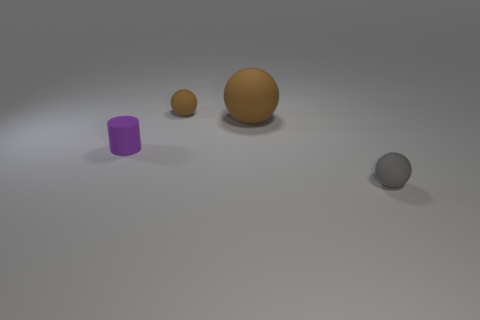Is there any other thing that has the same shape as the tiny purple matte object?
Your answer should be compact. No. What number of spheres are in front of the tiny brown matte sphere and behind the matte cylinder?
Give a very brief answer. 1. What shape is the tiny object behind the large object right of the small sphere that is on the left side of the gray ball?
Provide a succinct answer. Sphere. Are there the same number of brown rubber spheres in front of the rubber cylinder and gray things to the right of the tiny brown thing?
Give a very brief answer. No. What is the color of the rubber cylinder that is the same size as the gray ball?
Your answer should be compact. Purple. How many large things are either purple matte objects or brown shiny blocks?
Make the answer very short. 0. There is a tiny thing that is on the left side of the tiny gray object and in front of the big rubber thing; what material is it?
Provide a succinct answer. Rubber. There is a brown matte thing that is in front of the tiny brown matte ball; is its shape the same as the small rubber thing that is right of the small brown rubber ball?
Provide a short and direct response. Yes. There is a small matte thing that is the same color as the large rubber ball; what is its shape?
Your response must be concise. Sphere. How many objects are spheres behind the gray ball or large blue matte balls?
Keep it short and to the point. 2. 